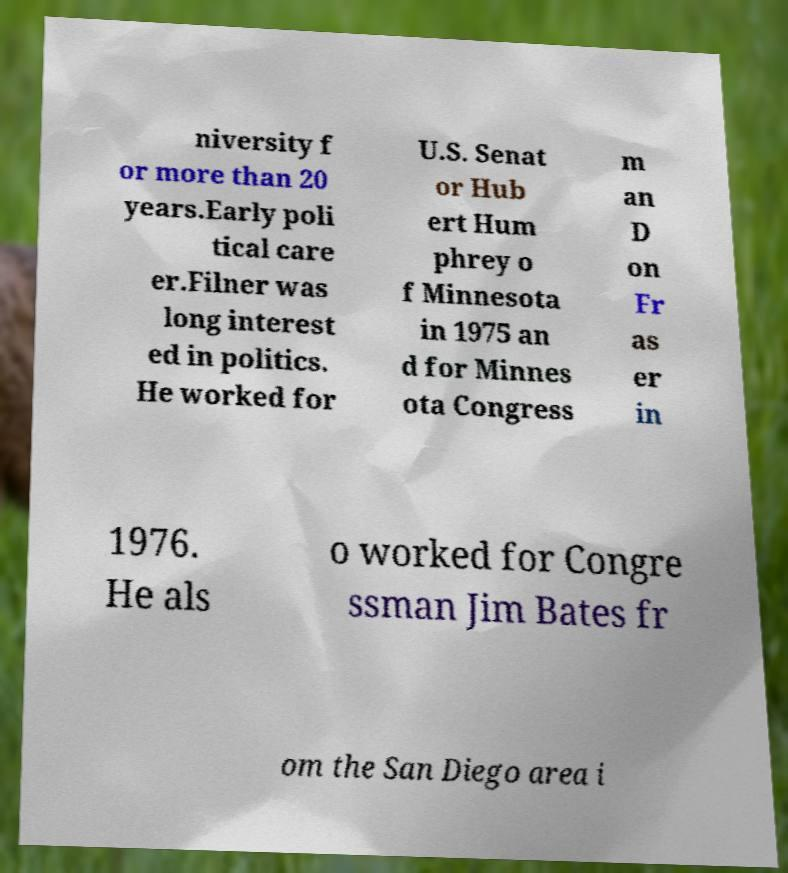What messages or text are displayed in this image? I need them in a readable, typed format. niversity f or more than 20 years.Early poli tical care er.Filner was long interest ed in politics. He worked for U.S. Senat or Hub ert Hum phrey o f Minnesota in 1975 an d for Minnes ota Congress m an D on Fr as er in 1976. He als o worked for Congre ssman Jim Bates fr om the San Diego area i 